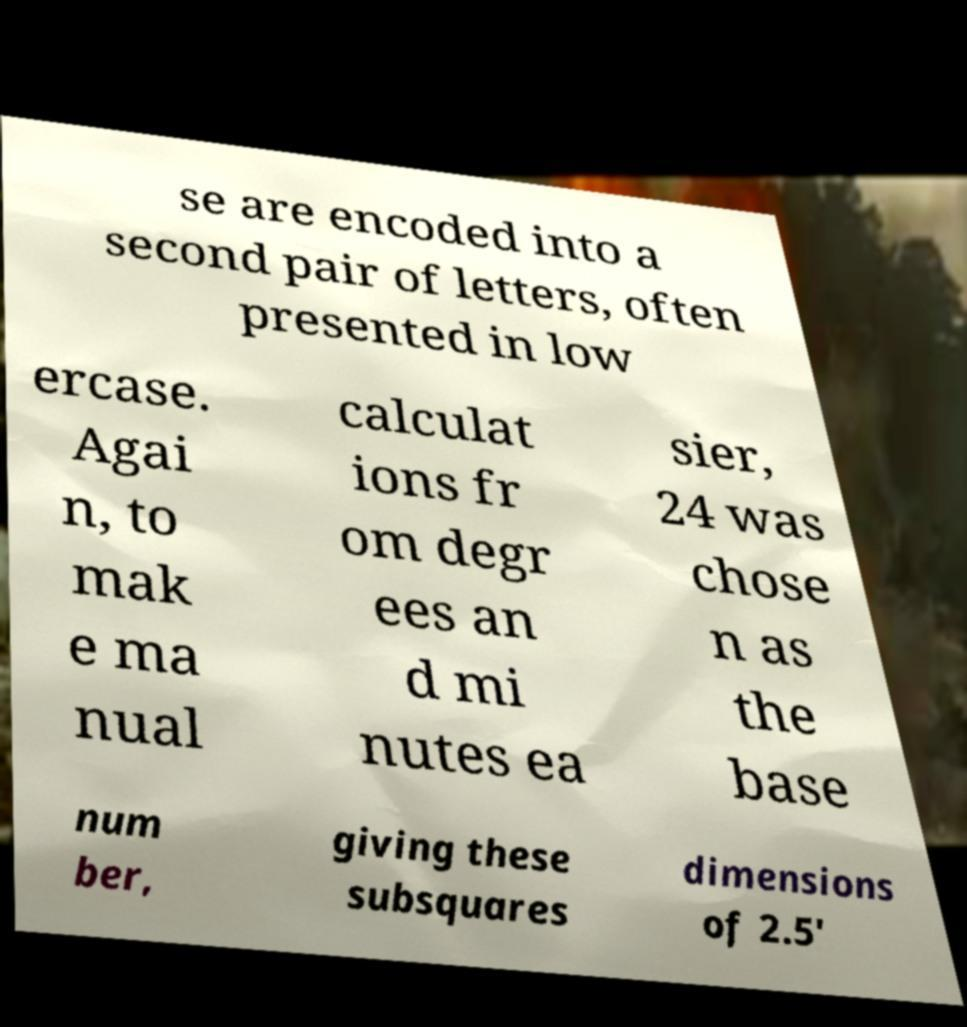Can you read and provide the text displayed in the image?This photo seems to have some interesting text. Can you extract and type it out for me? se are encoded into a second pair of letters, often presented in low ercase. Agai n, to mak e ma nual calculat ions fr om degr ees an d mi nutes ea sier, 24 was chose n as the base num ber, giving these subsquares dimensions of 2.5' 